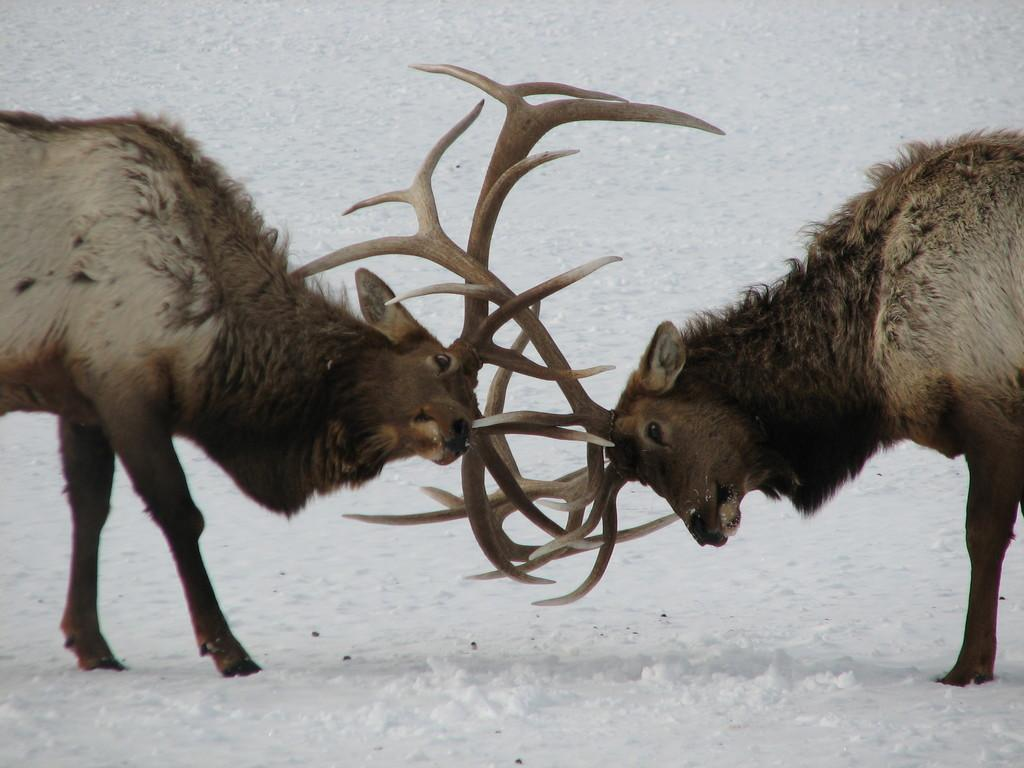What type of surface is visible in the image? The image shows a snow surface. What animals can be seen in the image? There are two stags in the image. What are the stags doing in the image? The stags are fighting with each other. How many trees can be seen in the image? There are no trees visible in the image; it shows a snow surface with two stags. What actor is performing in the image? There is no actor present in the image; it features two stags in a natural setting. 